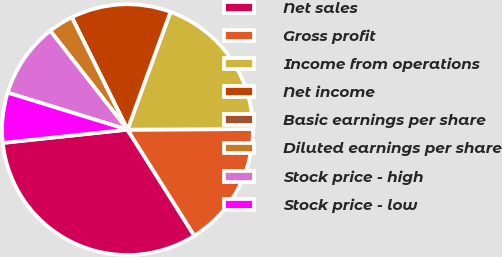Convert chart. <chart><loc_0><loc_0><loc_500><loc_500><pie_chart><fcel>Net sales<fcel>Gross profit<fcel>Income from operations<fcel>Net income<fcel>Basic earnings per share<fcel>Diluted earnings per share<fcel>Stock price - high<fcel>Stock price - low<nl><fcel>32.26%<fcel>16.13%<fcel>19.35%<fcel>12.9%<fcel>0.0%<fcel>3.23%<fcel>9.68%<fcel>6.45%<nl></chart> 